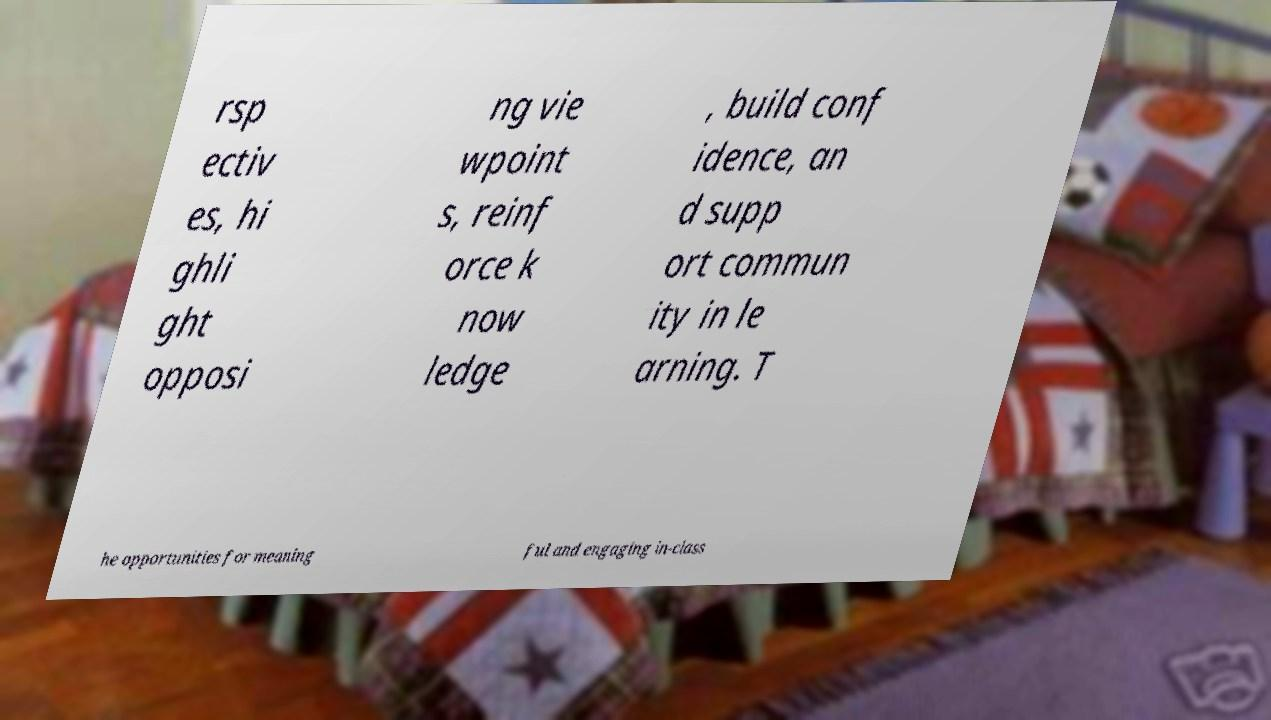Please identify and transcribe the text found in this image. rsp ectiv es, hi ghli ght opposi ng vie wpoint s, reinf orce k now ledge , build conf idence, an d supp ort commun ity in le arning. T he opportunities for meaning ful and engaging in-class 